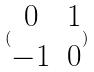<formula> <loc_0><loc_0><loc_500><loc_500>( \begin{matrix} 0 & 1 \\ - 1 & 0 \\ \end{matrix} )</formula> 